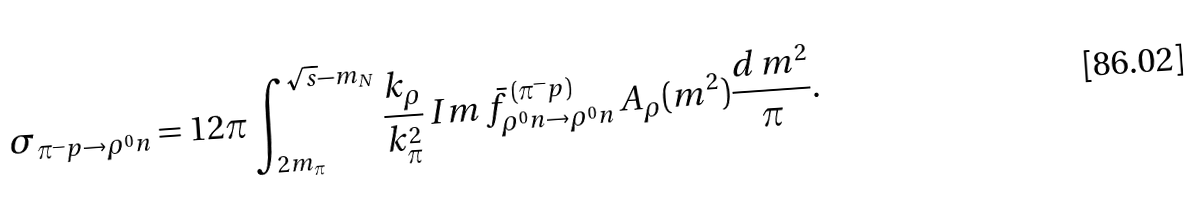<formula> <loc_0><loc_0><loc_500><loc_500>\sigma _ { \pi ^ { - } p \rightarrow \rho ^ { 0 } n } = 1 2 \pi \int _ { 2 m _ { \pi } } ^ { \sqrt { s } - m _ { N } } \frac { k _ { \rho } } { k _ { \pi } ^ { 2 } } \, I m \, \bar { f } _ { \rho ^ { 0 } n \rightarrow \rho ^ { 0 } n } ^ { \, ( \pi ^ { - } p ) } \, A _ { \rho } ( m ^ { 2 } ) \frac { d \, m ^ { 2 } } { \pi } .</formula> 